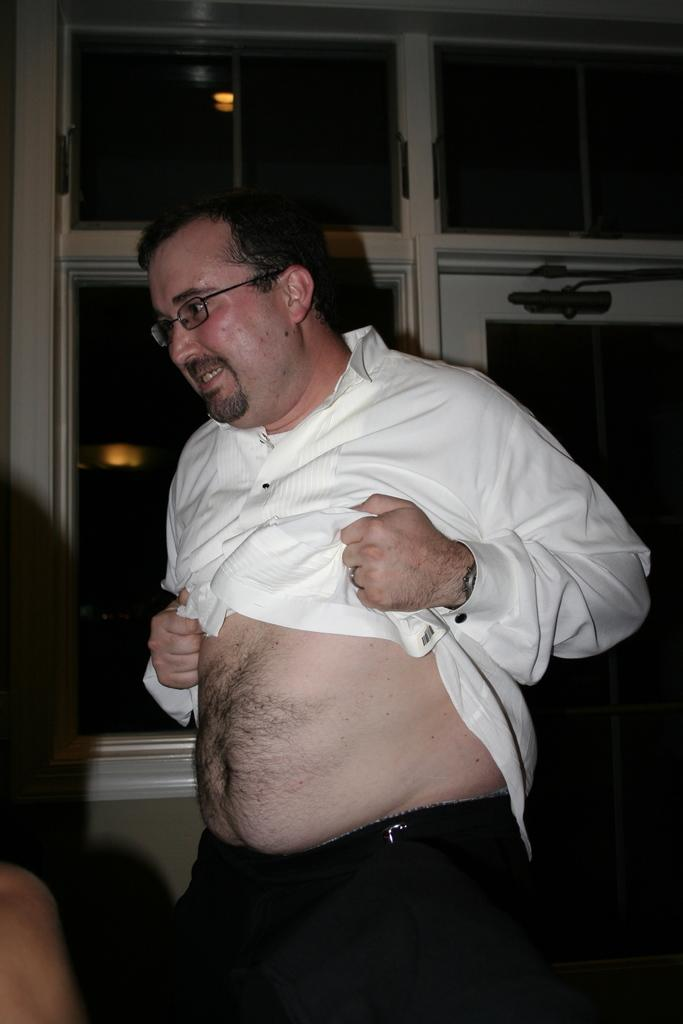Who is present in the image? There is a man in the image. What can be observed about the man's appearance? The man is wearing spectacles and a white color shirt. What can be seen in the background of the image? There are lights visible in the background of the image. Are there any other people in the image? Yes, there are people in front of the man. What verse is the man reciting in the image? There is no indication in the image that the man is reciting a verse, so it cannot be determined from the picture. 